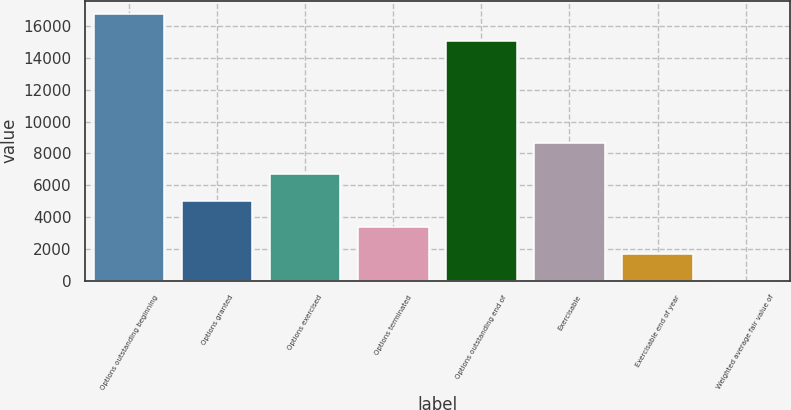<chart> <loc_0><loc_0><loc_500><loc_500><bar_chart><fcel>Options outstanding beginning<fcel>Options granted<fcel>Options exercised<fcel>Options terminated<fcel>Options outstanding end of<fcel>Exercisable<fcel>Exercisable end of year<fcel>Weighted average fair value of<nl><fcel>16752<fcel>5035.5<fcel>6709.28<fcel>3361.72<fcel>15048<fcel>8660<fcel>1687.93<fcel>14.15<nl></chart> 